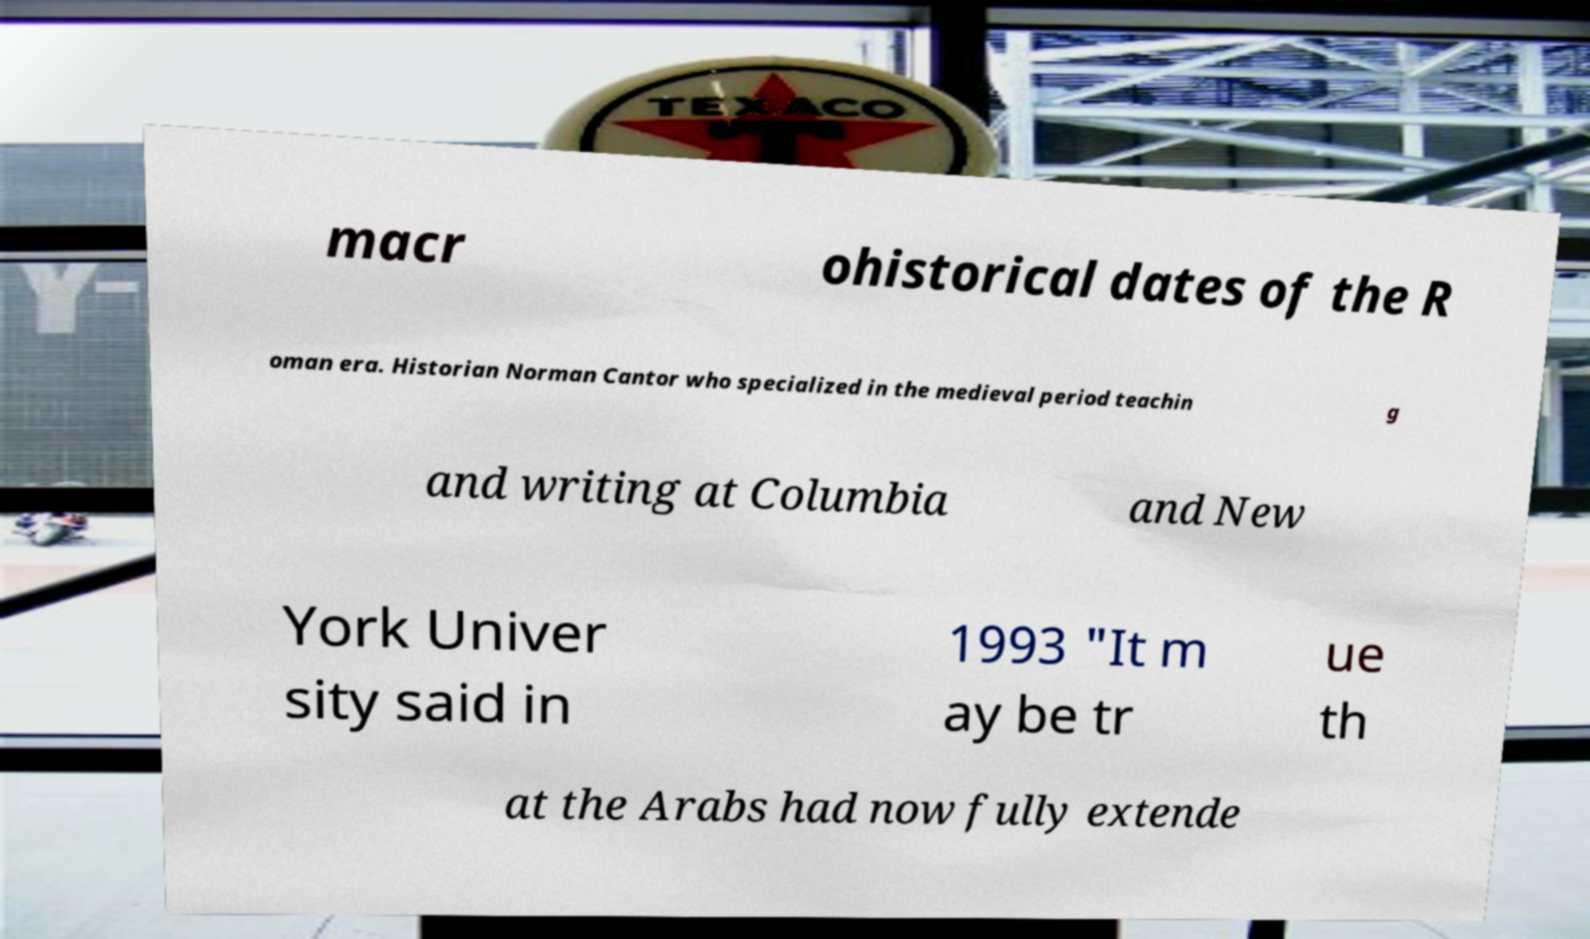What messages or text are displayed in this image? I need them in a readable, typed format. macr ohistorical dates of the R oman era. Historian Norman Cantor who specialized in the medieval period teachin g and writing at Columbia and New York Univer sity said in 1993 "It m ay be tr ue th at the Arabs had now fully extende 